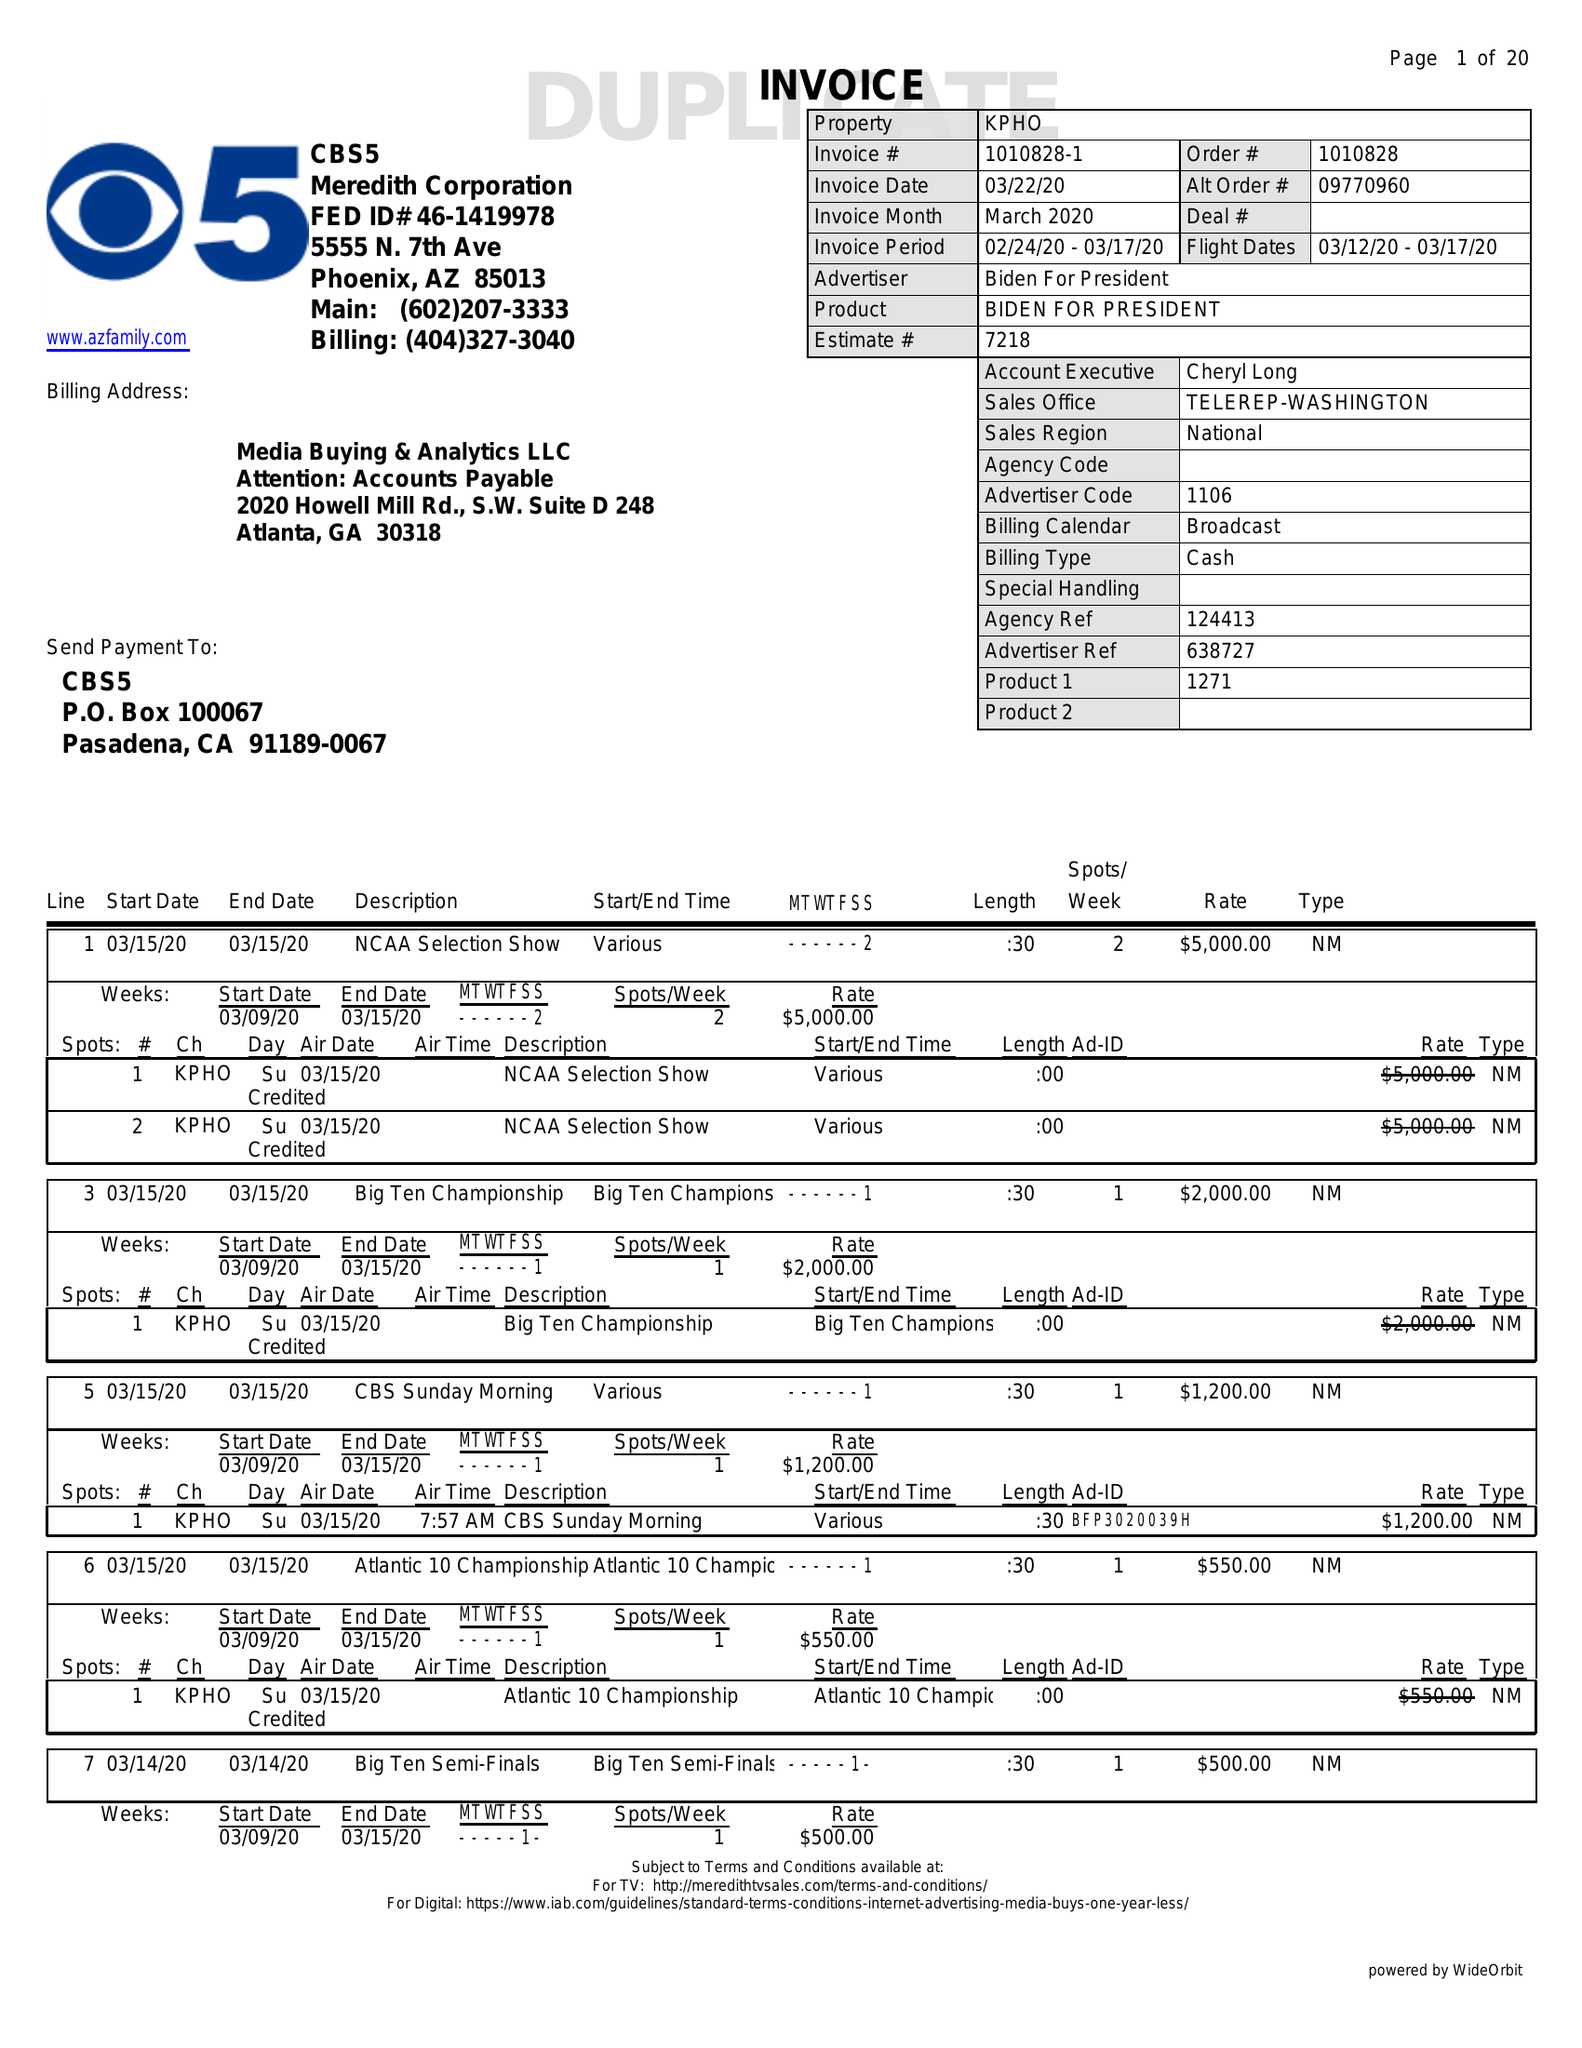What is the value for the advertiser?
Answer the question using a single word or phrase. BIDEN FOR PRESIDENT 